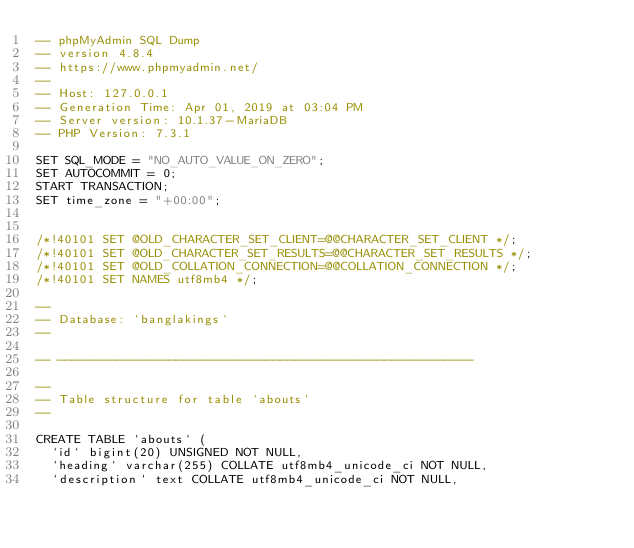<code> <loc_0><loc_0><loc_500><loc_500><_SQL_>-- phpMyAdmin SQL Dump
-- version 4.8.4
-- https://www.phpmyadmin.net/
--
-- Host: 127.0.0.1
-- Generation Time: Apr 01, 2019 at 03:04 PM
-- Server version: 10.1.37-MariaDB
-- PHP Version: 7.3.1

SET SQL_MODE = "NO_AUTO_VALUE_ON_ZERO";
SET AUTOCOMMIT = 0;
START TRANSACTION;
SET time_zone = "+00:00";


/*!40101 SET @OLD_CHARACTER_SET_CLIENT=@@CHARACTER_SET_CLIENT */;
/*!40101 SET @OLD_CHARACTER_SET_RESULTS=@@CHARACTER_SET_RESULTS */;
/*!40101 SET @OLD_COLLATION_CONNECTION=@@COLLATION_CONNECTION */;
/*!40101 SET NAMES utf8mb4 */;

--
-- Database: `banglakings`
--

-- --------------------------------------------------------

--
-- Table structure for table `abouts`
--

CREATE TABLE `abouts` (
  `id` bigint(20) UNSIGNED NOT NULL,
  `heading` varchar(255) COLLATE utf8mb4_unicode_ci NOT NULL,
  `description` text COLLATE utf8mb4_unicode_ci NOT NULL,</code> 